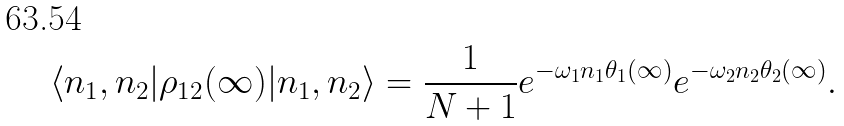Convert formula to latex. <formula><loc_0><loc_0><loc_500><loc_500>\langle n _ { 1 } , n _ { 2 } | \rho _ { 1 2 } ( \infty ) | n _ { 1 } , n _ { 2 } \rangle = \frac { 1 } { N + 1 } e ^ { - \omega _ { 1 } n _ { 1 } \theta _ { 1 } ( \infty ) } e ^ { - \omega _ { 2 } n _ { 2 } \theta _ { 2 } ( \infty ) } .</formula> 